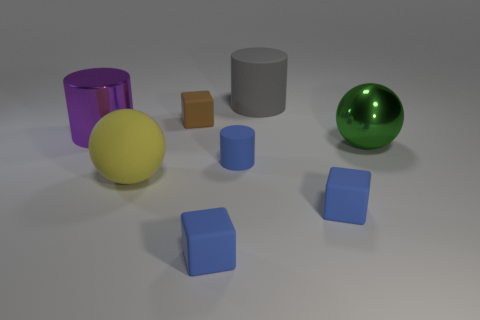Add 2 tiny gray blocks. How many objects exist? 10 Subtract all spheres. How many objects are left? 6 Add 8 big shiny cylinders. How many big shiny cylinders exist? 9 Subtract 0 cyan blocks. How many objects are left? 8 Subtract all tiny blue matte cylinders. Subtract all big shiny spheres. How many objects are left? 6 Add 3 large gray objects. How many large gray objects are left? 4 